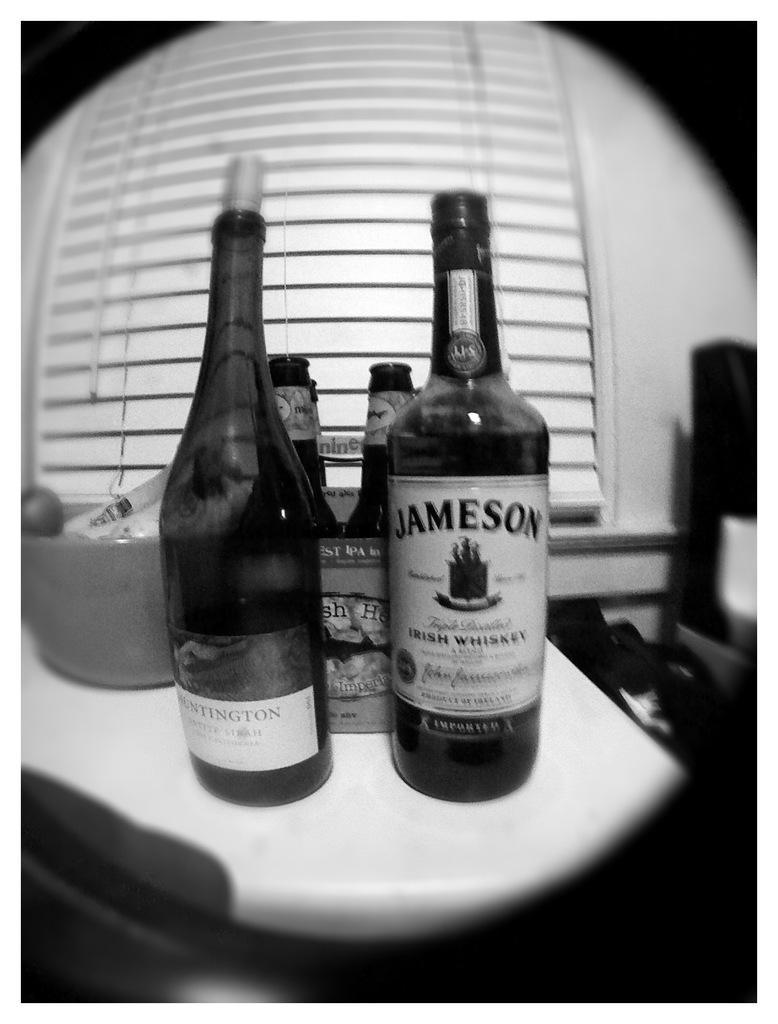How would you summarize this image in a sentence or two? This is of a black and white picture. These are the wine bottles placed on the table. This looks like a bowl with some things inside it. 